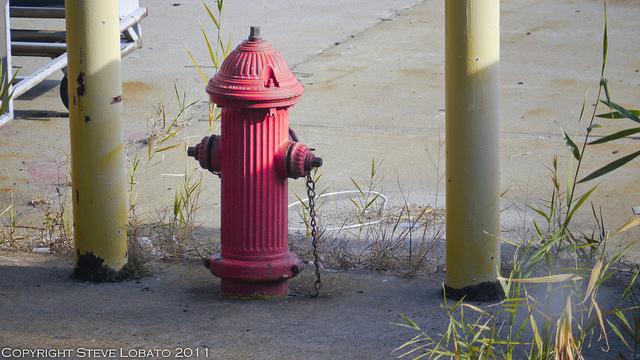Are any cars visible?
Write a very short answer. No. Is the gate too close to the fire hydrant?
Write a very short answer. No. Does the water hydrant work?
Short answer required. Yes. Are any of the poles rusty?
Short answer required. Yes. How many poles are there?
Quick response, please. 2. 